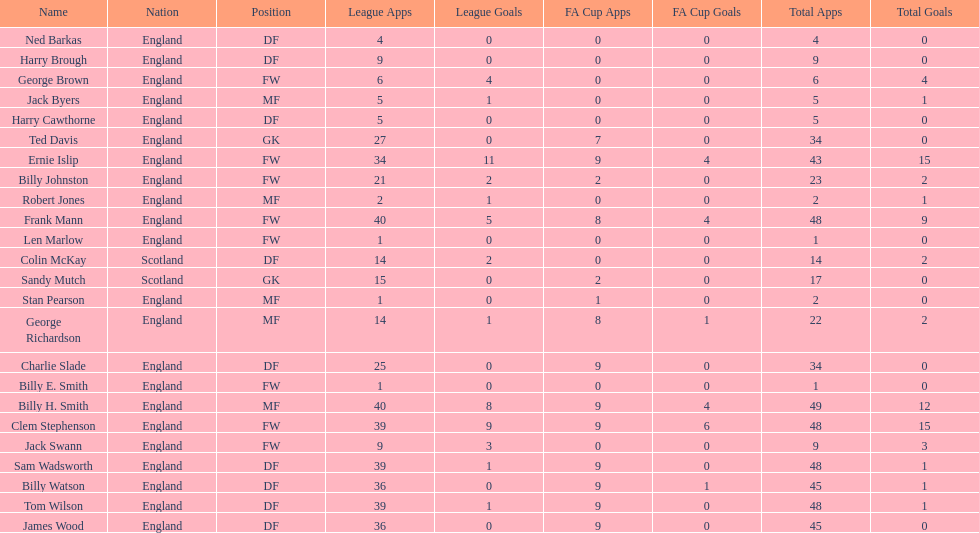How many players are fws? 8. 